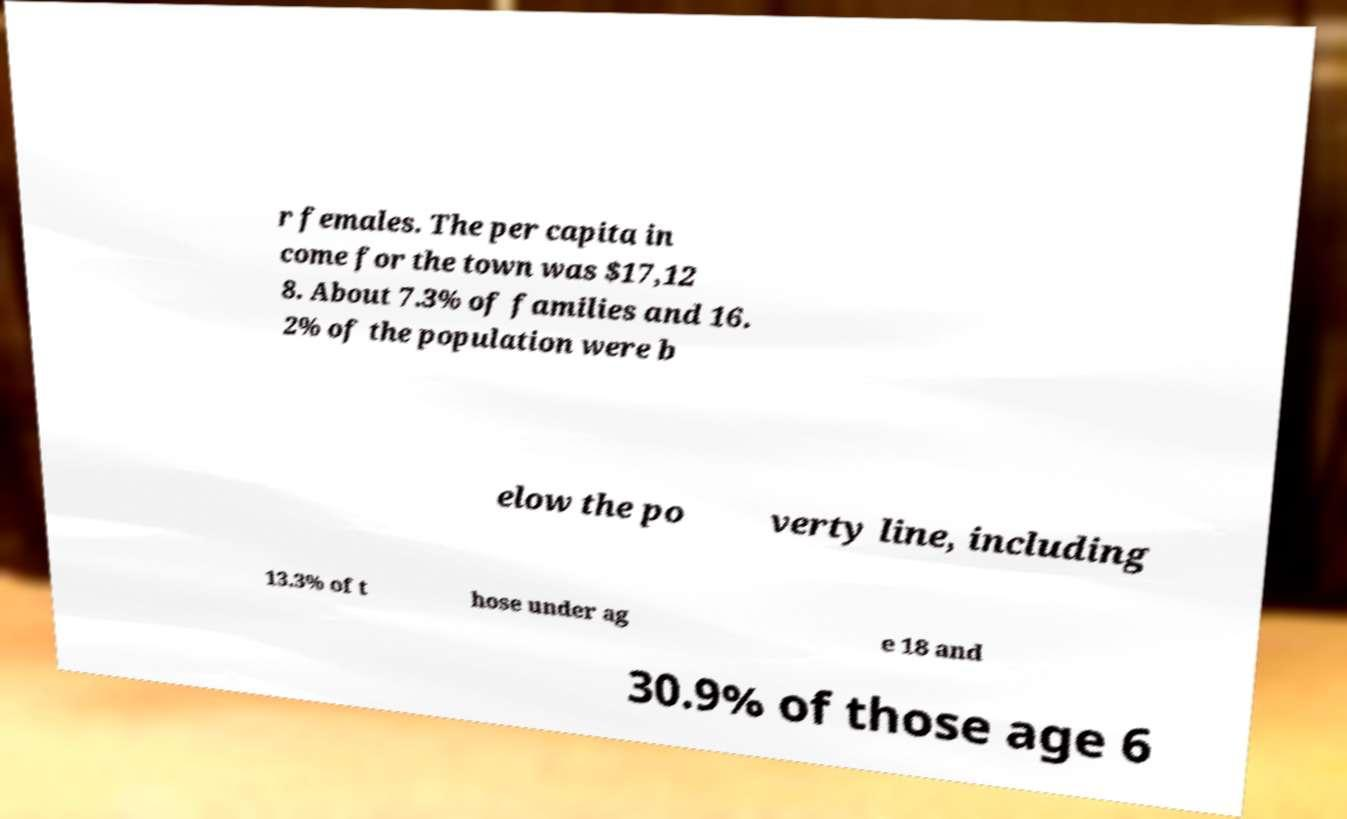Please read and relay the text visible in this image. What does it say? r females. The per capita in come for the town was $17,12 8. About 7.3% of families and 16. 2% of the population were b elow the po verty line, including 13.3% of t hose under ag e 18 and 30.9% of those age 6 